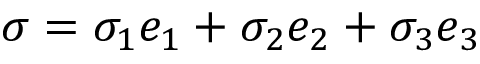Convert formula to latex. <formula><loc_0><loc_0><loc_500><loc_500>\sigma = \sigma _ { 1 } e _ { 1 } + \sigma _ { 2 } e _ { 2 } + \sigma _ { 3 } e _ { 3 }</formula> 